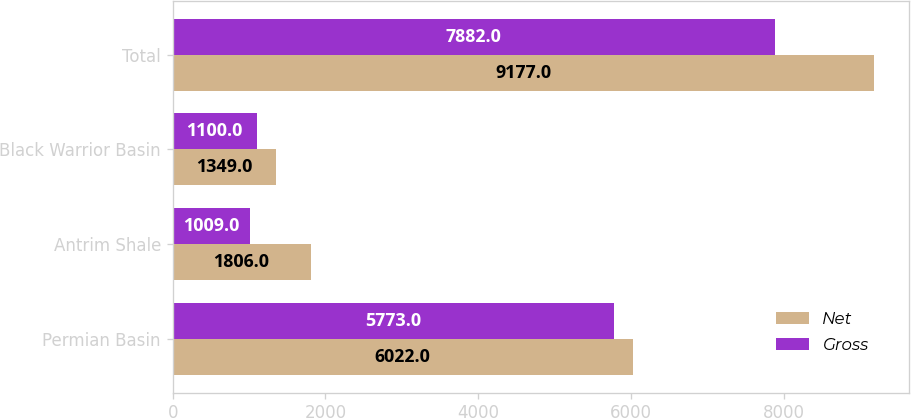<chart> <loc_0><loc_0><loc_500><loc_500><stacked_bar_chart><ecel><fcel>Permian Basin<fcel>Antrim Shale<fcel>Black Warrior Basin<fcel>Total<nl><fcel>Net<fcel>6022<fcel>1806<fcel>1349<fcel>9177<nl><fcel>Gross<fcel>5773<fcel>1009<fcel>1100<fcel>7882<nl></chart> 